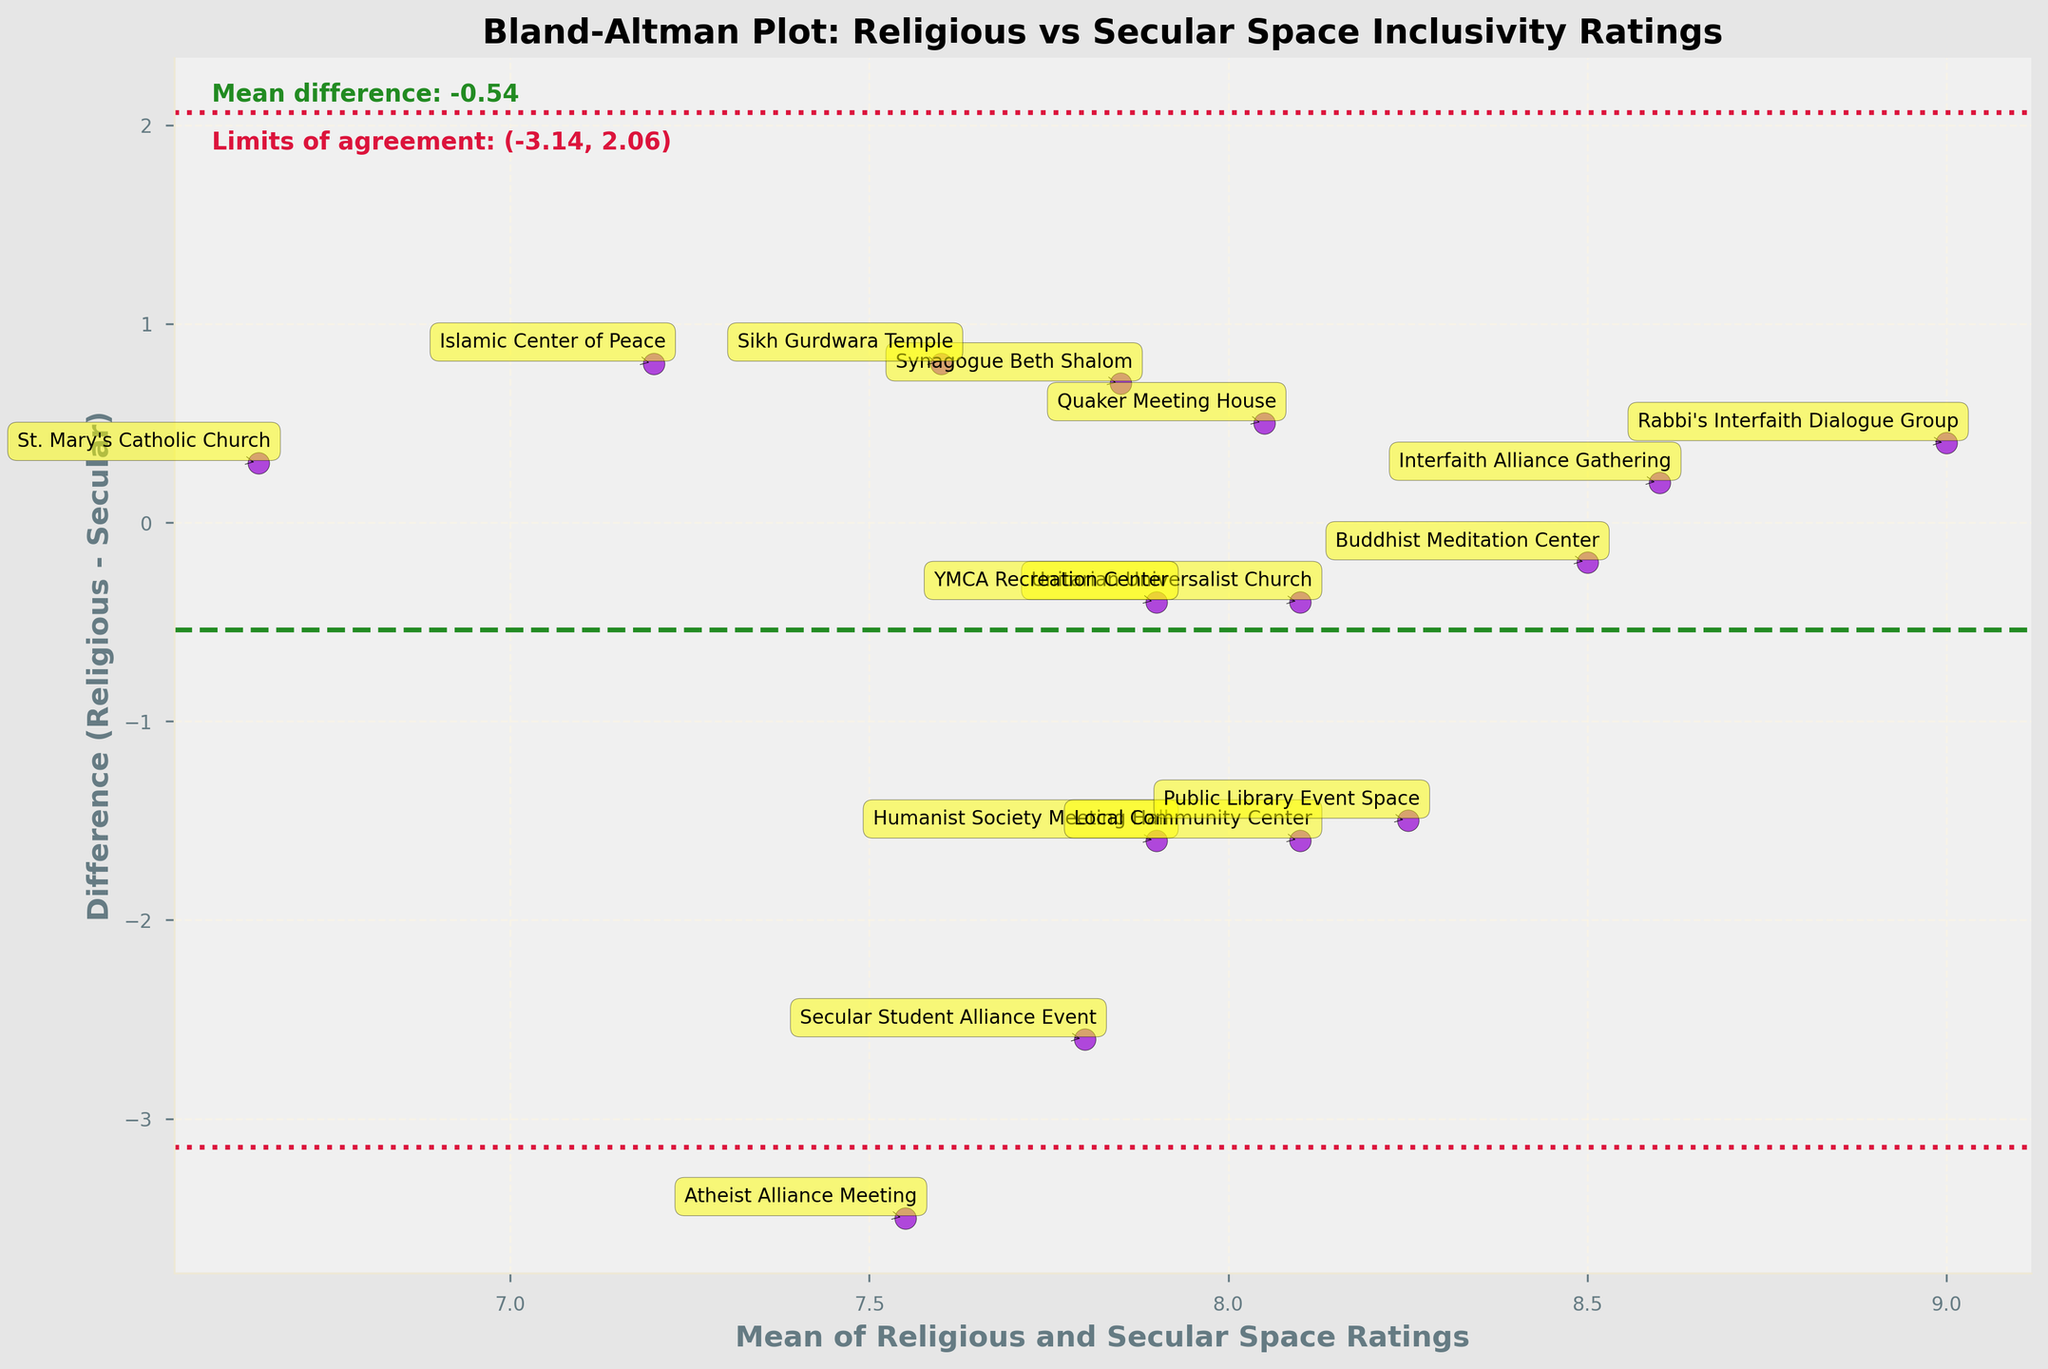What is the title of the plot? The title is usually displayed at the top of the plot. It is typically bold and describes what the plot shows.
Answer: Bland-Altman Plot: Religious vs Secular Space Inclusivity Ratings How many data points are there in the plot? Count the number of individual markers or annotations representing the data points.
Answer: 15 What does the x-axis represent? The x-axis label is usually described at the bottom of the x-axis in bold letters.
Answer: Mean of Religious and Secular Space Ratings What is the mean difference between Religious and Secular space ratings? The mean difference is given as a text annotation near the top of the plot.
Answer: 0.07 Which venue has the lowest difference between Religious and Secular ratings? Identify the data point closest to the horizontal line representing the mean difference of zero and match it with the provided annotations.
Answer: St. Mary's Catholic Church What are the limits of agreement on the plot? The limits of agreement are usually annotated as horizontal lines, with values given as text.
Answer: (-1.39, 1.53) What is the color of the data points? Observe the color used for the majority of scatter points within the plot.
Answer: Dark violet Which venue has the highest mean rating? Compare the x-axis values of all data points to identify the highest value and refer to the corresponding annotation.
Answer: Public Library Event Space How is the YMCA Recreation Center rated in religious vs secular spaces? Look at the annotation for YMCA Recreation Center to find its position on both the x and y axes: x-axis (mean rating) and y-axis (difference).
Answer: Mean: 7.9, Difference: -0.4 Which venue has the largest absolute difference in inclusivity ratings? Identify the point furthest from the mean difference of zero, indicating the largest absolute discrepancy.
Answer: Secular Student Alliance Event 